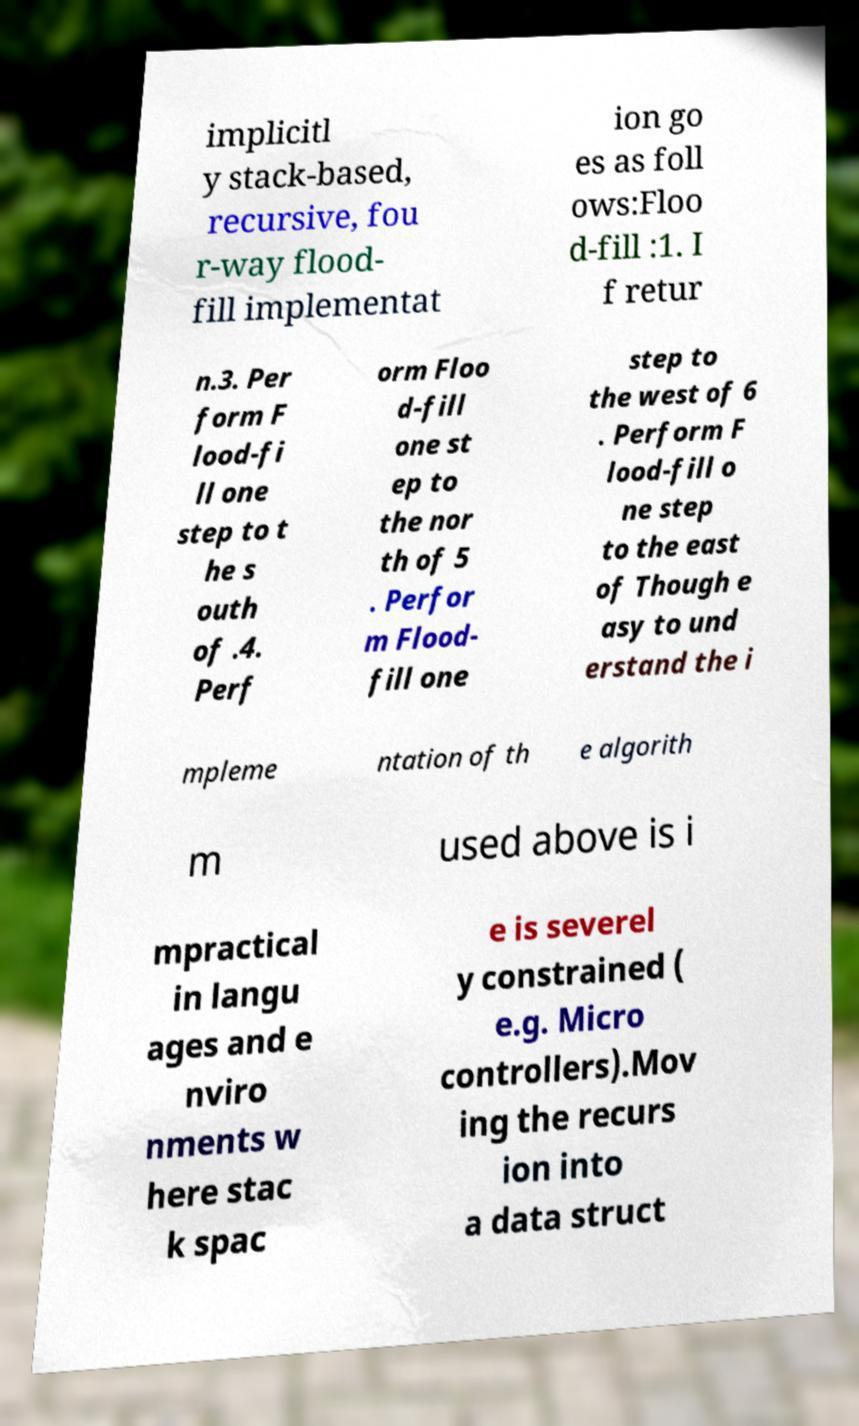I need the written content from this picture converted into text. Can you do that? implicitl y stack-based, recursive, fou r-way flood- fill implementat ion go es as foll ows:Floo d-fill :1. I f retur n.3. Per form F lood-fi ll one step to t he s outh of .4. Perf orm Floo d-fill one st ep to the nor th of 5 . Perfor m Flood- fill one step to the west of 6 . Perform F lood-fill o ne step to the east of Though e asy to und erstand the i mpleme ntation of th e algorith m used above is i mpractical in langu ages and e nviro nments w here stac k spac e is severel y constrained ( e.g. Micro controllers).Mov ing the recurs ion into a data struct 